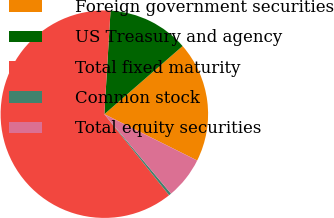<chart> <loc_0><loc_0><loc_500><loc_500><pie_chart><fcel>Foreign government securities<fcel>US Treasury and agency<fcel>Total fixed maturity<fcel>Common stock<fcel>Total equity securities<nl><fcel>18.77%<fcel>12.65%<fcel>61.67%<fcel>0.39%<fcel>6.52%<nl></chart> 